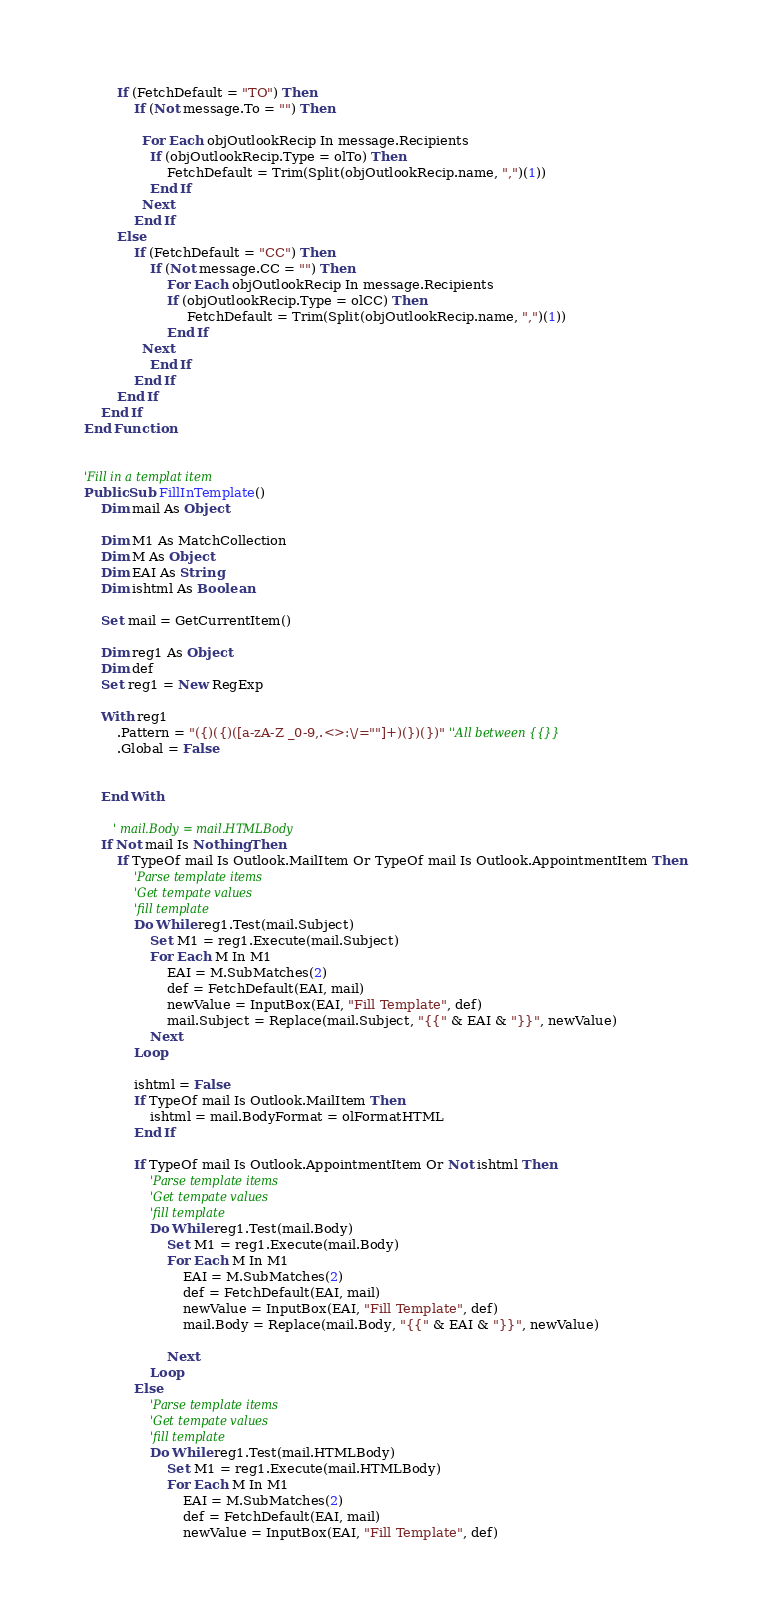<code> <loc_0><loc_0><loc_500><loc_500><_VisualBasic_>        If (FetchDefault = "TO") Then
            If (Not message.To = "") Then
            
              For Each objOutlookRecip In message.Recipients
                If (objOutlookRecip.Type = olTo) Then
                    FetchDefault = Trim(Split(objOutlookRecip.name, ",")(1))
                End If
              Next
            End If
        Else
            If (FetchDefault = "CC") Then
                If (Not message.CC = "") Then
                    For Each objOutlookRecip In message.Recipients
                    If (objOutlookRecip.Type = olCC) Then
                         FetchDefault = Trim(Split(objOutlookRecip.name, ",")(1))
                    End If
              Next
                End If
            End If
        End If
    End If
End Function


'Fill in a templat item
Public Sub FillInTemplate()
    Dim mail As Object
    
    Dim M1 As MatchCollection
    Dim M As Object
    Dim EAI As String
    Dim ishtml As Boolean
    
    Set mail = GetCurrentItem()
    
    Dim reg1 As Object
    Dim def
    Set reg1 = New RegExp

    With reg1
        .Pattern = "({)({)([a-zA-Z _0-9,.<>:\/=""]+)(})(})" ''All between {{}}
        .Global = False
        
        
    End With
        
       ' mail.Body = mail.HTMLBody
    If Not mail Is Nothing Then
        If TypeOf mail Is Outlook.MailItem Or TypeOf mail Is Outlook.AppointmentItem Then
            'Parse template items
            'Get tempate values
            'fill template
            Do While reg1.Test(mail.Subject)
                Set M1 = reg1.Execute(mail.Subject)
                For Each M In M1
                    EAI = M.SubMatches(2)
                    def = FetchDefault(EAI, mail)
                    newValue = InputBox(EAI, "Fill Template", def)
                    mail.Subject = Replace(mail.Subject, "{{" & EAI & "}}", newValue)
                Next
            Loop
            
            ishtml = False
            If TypeOf mail Is Outlook.MailItem Then
                ishtml = mail.BodyFormat = olFormatHTML
            End If
            
            If TypeOf mail Is Outlook.AppointmentItem Or Not ishtml Then
                'Parse template items
                'Get tempate values
                'fill template
                Do While reg1.Test(mail.Body)
                    Set M1 = reg1.Execute(mail.Body)
                    For Each M In M1
                        EAI = M.SubMatches(2)
                        def = FetchDefault(EAI, mail)
                        newValue = InputBox(EAI, "Fill Template", def)
                        mail.Body = Replace(mail.Body, "{{" & EAI & "}}", newValue)

                    Next
                Loop
            Else
                'Parse template items
                'Get tempate values
                'fill template
                Do While reg1.Test(mail.HTMLBody)
                    Set M1 = reg1.Execute(mail.HTMLBody)
                    For Each M In M1
                        EAI = M.SubMatches(2)
                        def = FetchDefault(EAI, mail)
                        newValue = InputBox(EAI, "Fill Template", def)</code> 